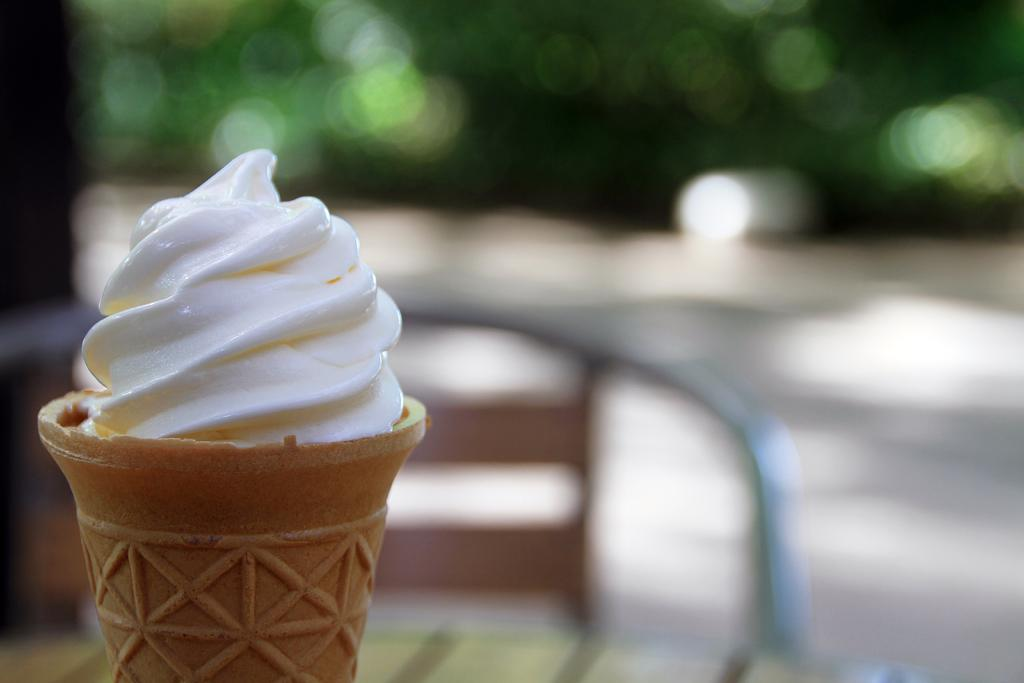What is the main subject of the image? The main subject of the image is an ice cream. What type of furniture is present in the image? There is a table and a chair in the image. How would you describe the background of the image? The background of the image is blurred. What type of sail can be seen on the ice cream in the image? There is no sail present on the ice cream in the image. 